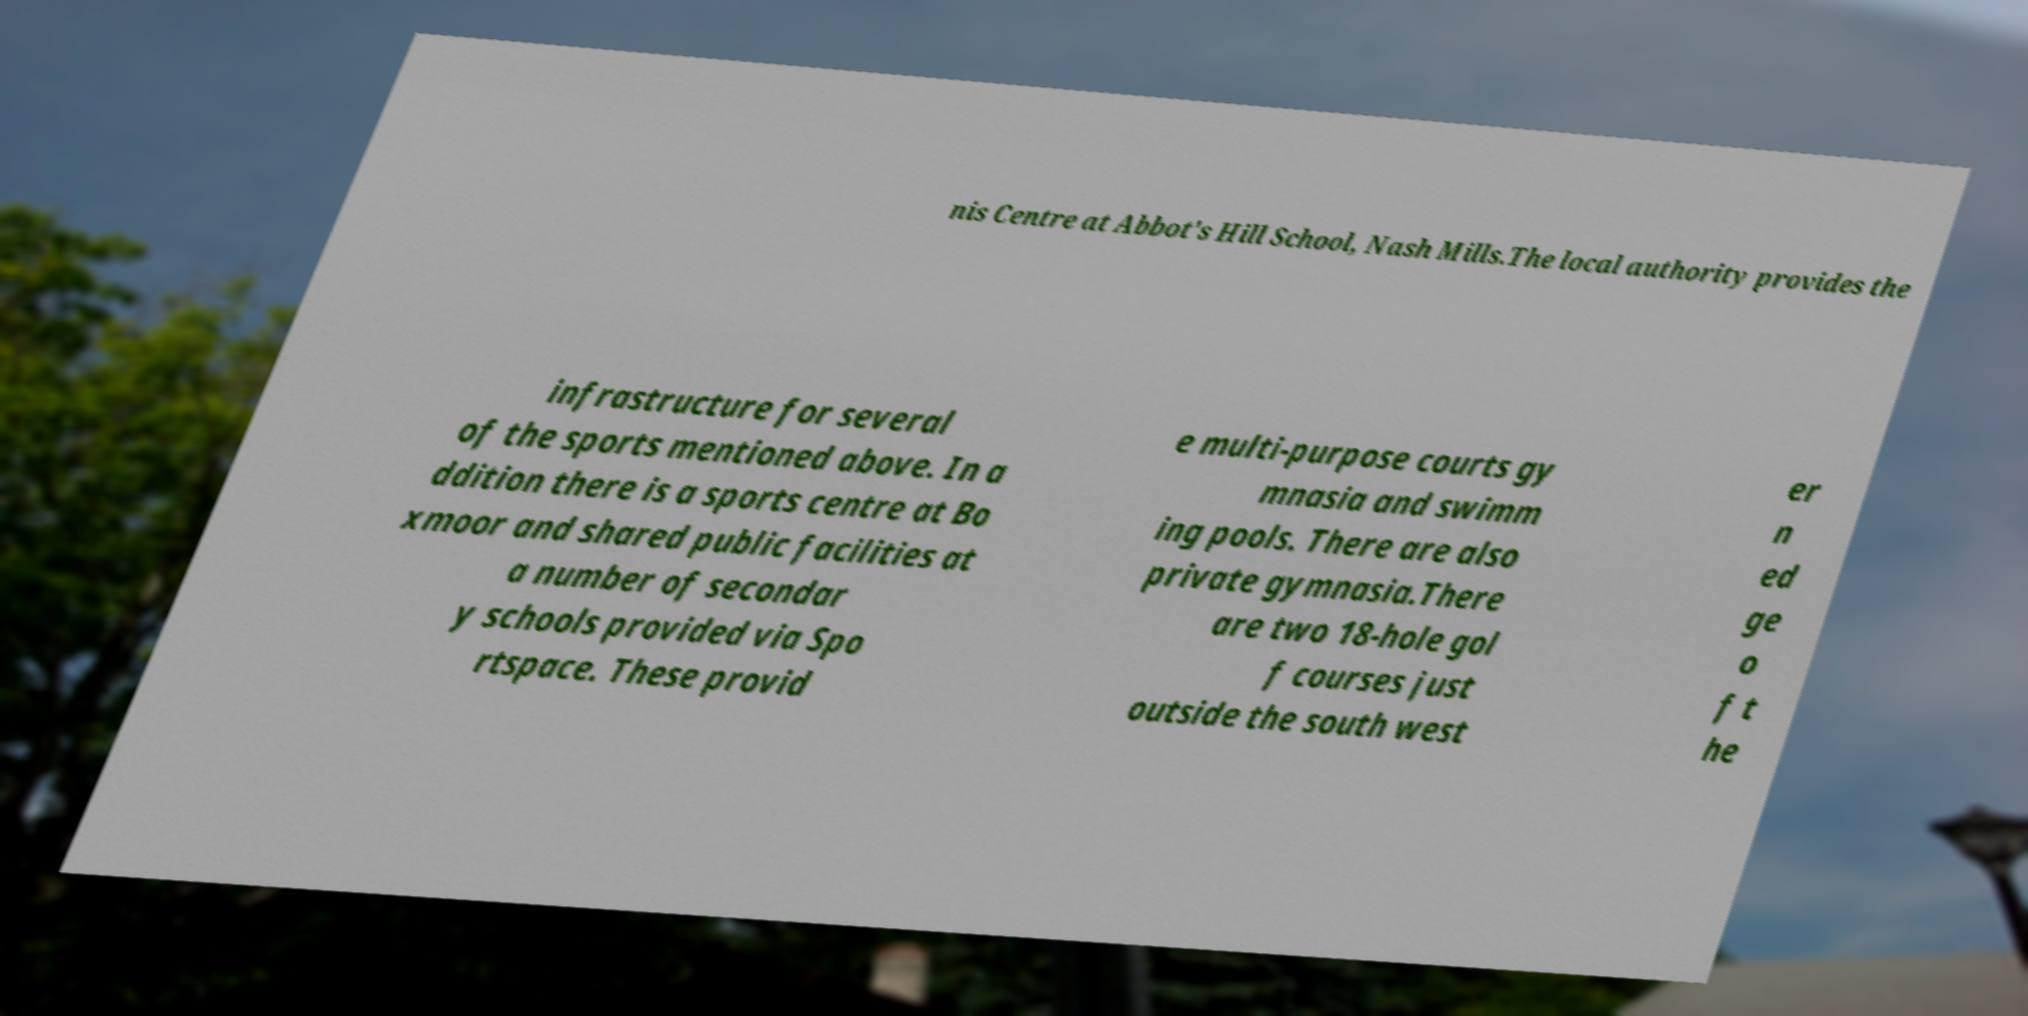Please read and relay the text visible in this image. What does it say? nis Centre at Abbot's Hill School, Nash Mills.The local authority provides the infrastructure for several of the sports mentioned above. In a ddition there is a sports centre at Bo xmoor and shared public facilities at a number of secondar y schools provided via Spo rtspace. These provid e multi-purpose courts gy mnasia and swimm ing pools. There are also private gymnasia.There are two 18-hole gol f courses just outside the south west er n ed ge o f t he 